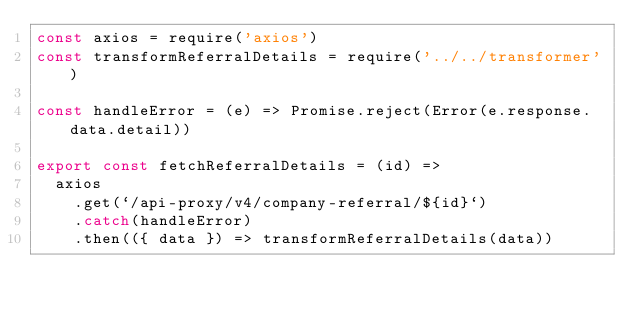Convert code to text. <code><loc_0><loc_0><loc_500><loc_500><_JavaScript_>const axios = require('axios')
const transformReferralDetails = require('../../transformer')

const handleError = (e) => Promise.reject(Error(e.response.data.detail))

export const fetchReferralDetails = (id) =>
  axios
    .get(`/api-proxy/v4/company-referral/${id}`)
    .catch(handleError)
    .then(({ data }) => transformReferralDetails(data))
</code> 